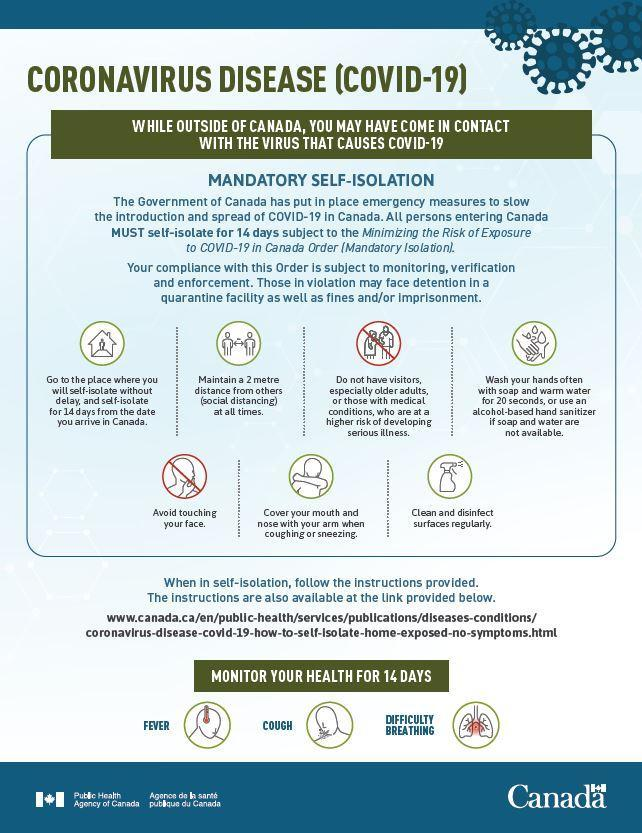What are the common symptoms of COVID-19?
Answer the question with a short phrase. Fever, Cough, Difficulty breathing What is the minimum safe distance to be maintained between yourself & others inorder to control the spread of COVID-19 virus? 2 metre 